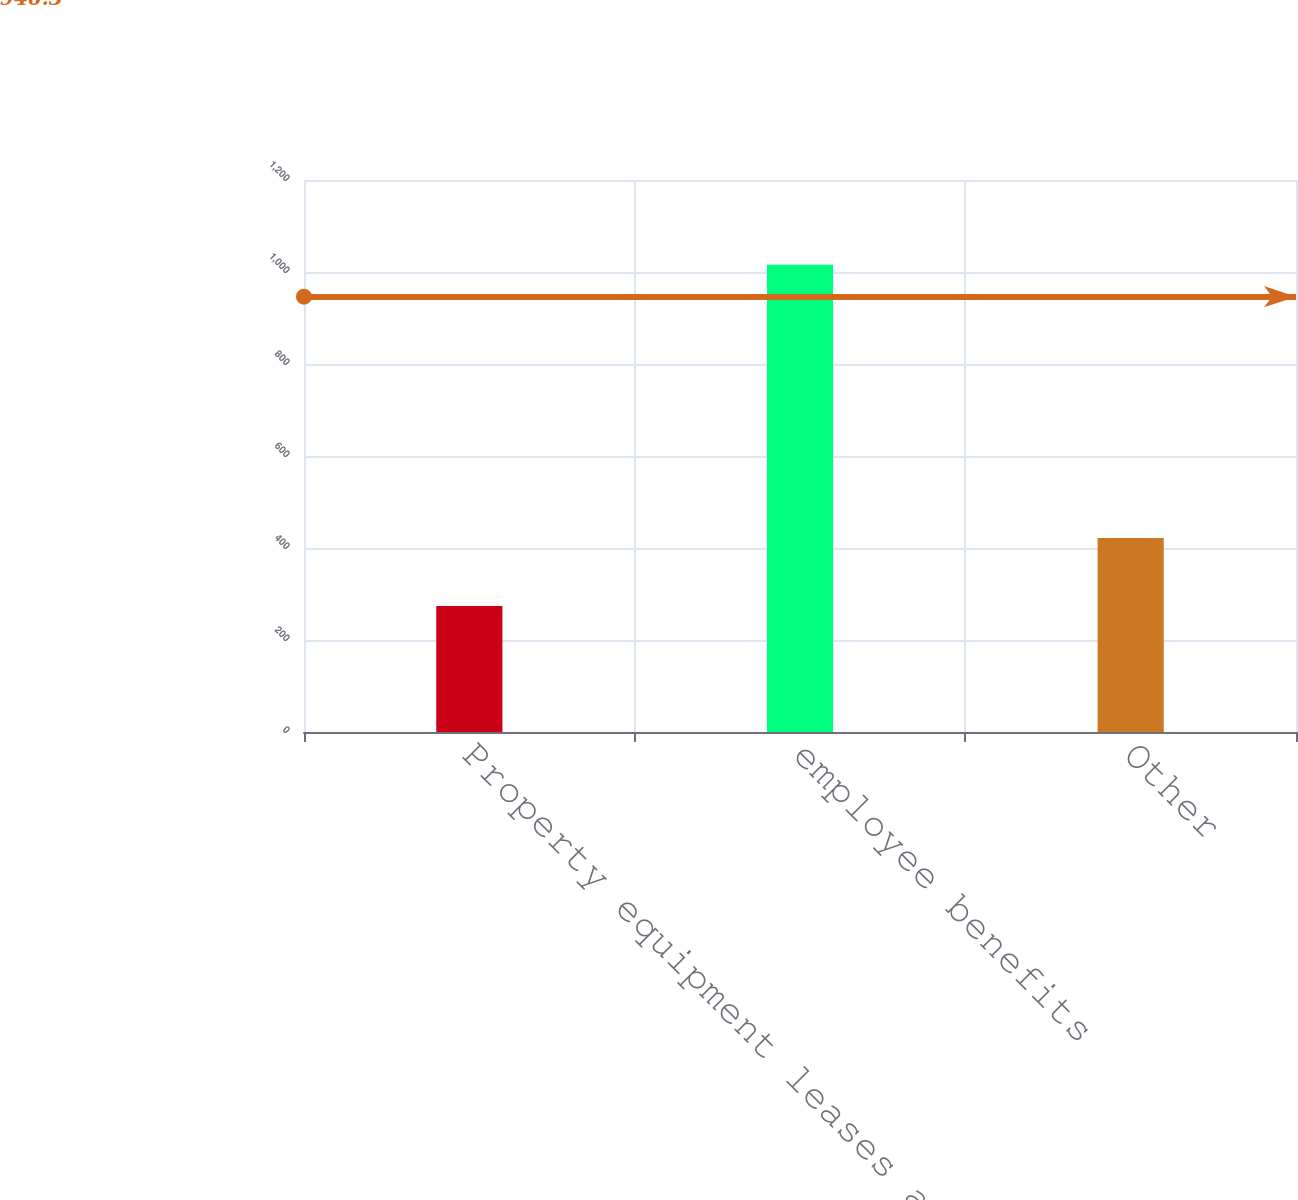<chart> <loc_0><loc_0><loc_500><loc_500><bar_chart><fcel>Property equipment leases and<fcel>employee benefits<fcel>Other<nl><fcel>274<fcel>1016<fcel>422<nl></chart> 